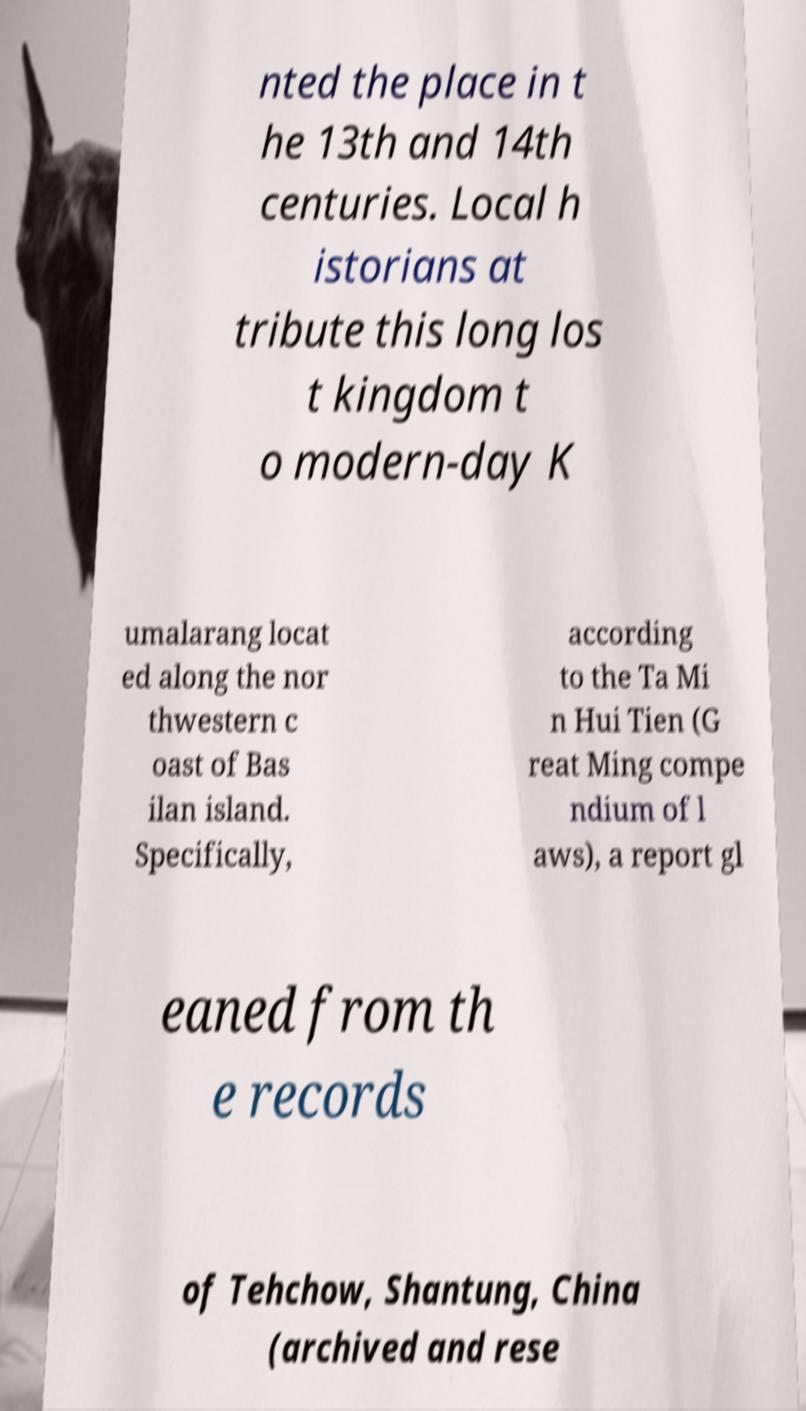Can you accurately transcribe the text from the provided image for me? nted the place in t he 13th and 14th centuries. Local h istorians at tribute this long los t kingdom t o modern-day K umalarang locat ed along the nor thwestern c oast of Bas ilan island. Specifically, according to the Ta Mi n Hui Tien (G reat Ming compe ndium of l aws), a report gl eaned from th e records of Tehchow, Shantung, China (archived and rese 